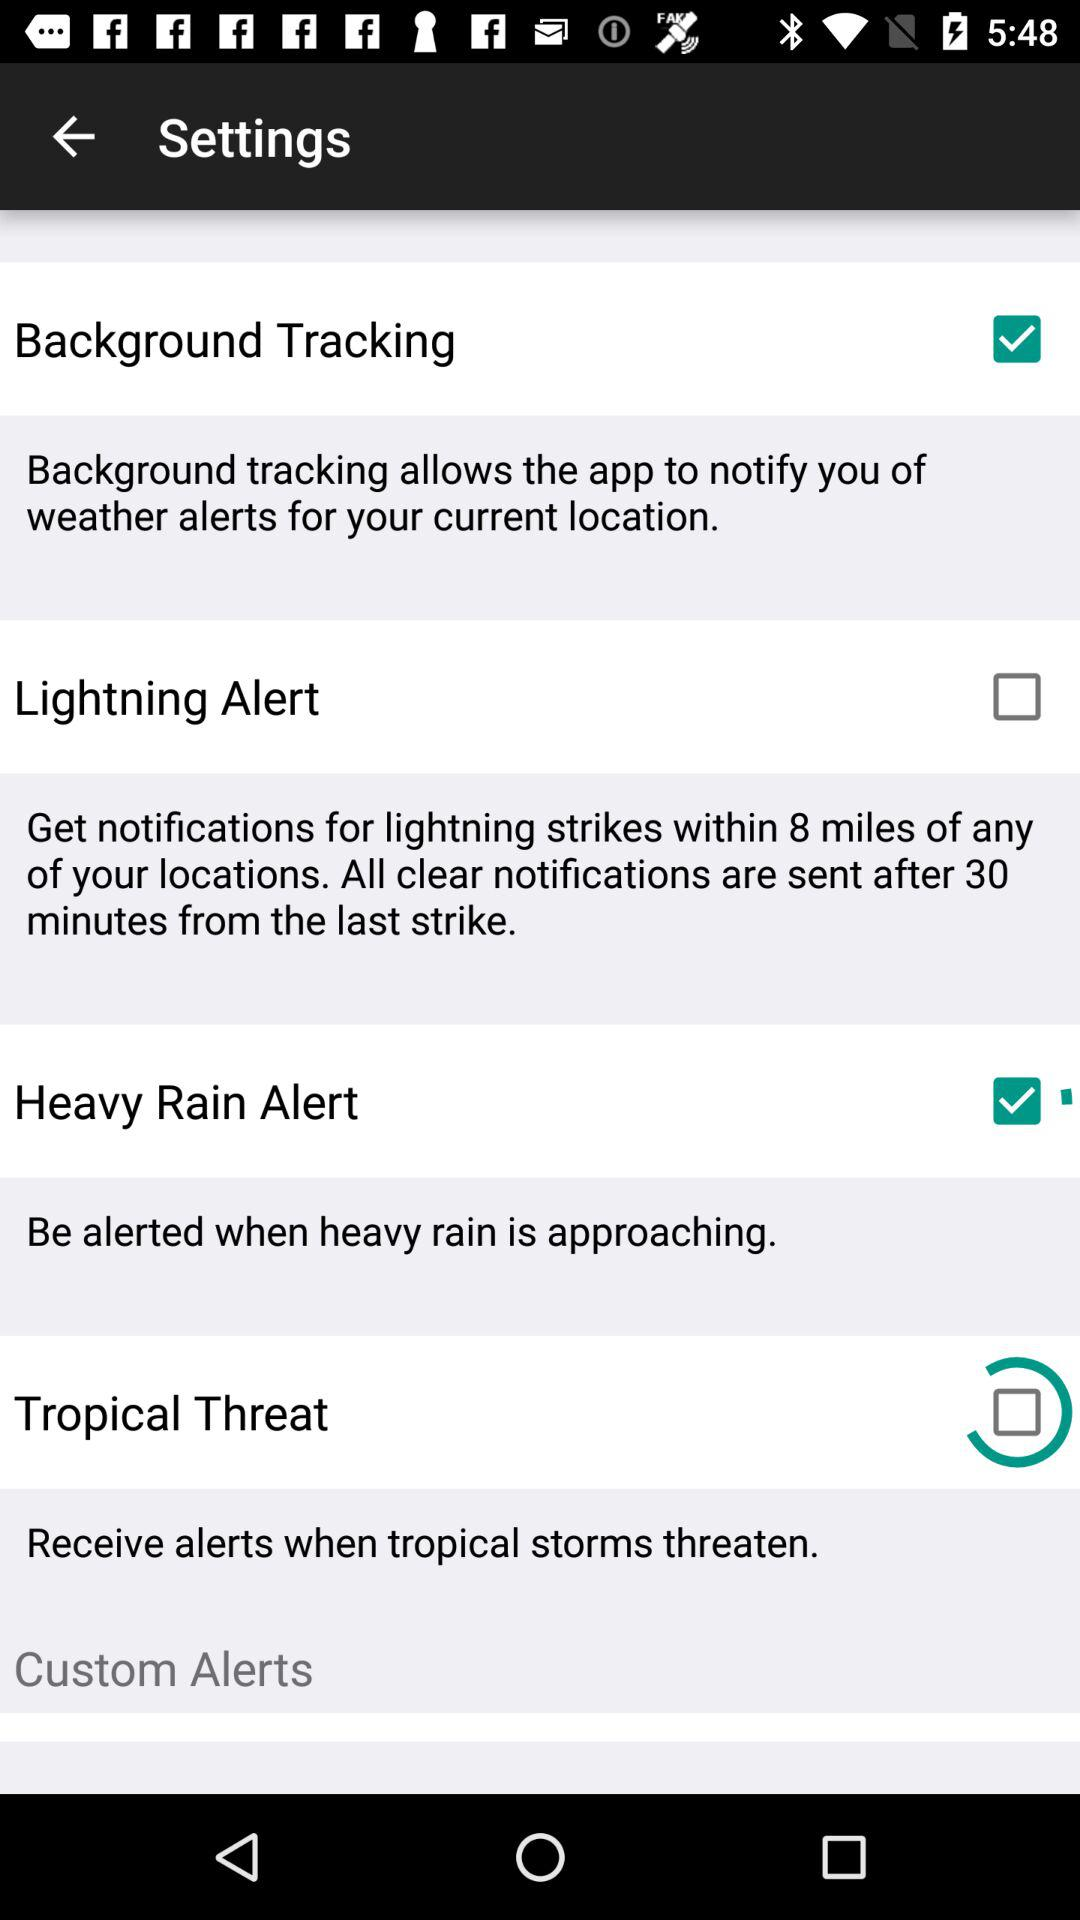How many alert types are there?
Answer the question using a single word or phrase. 4 